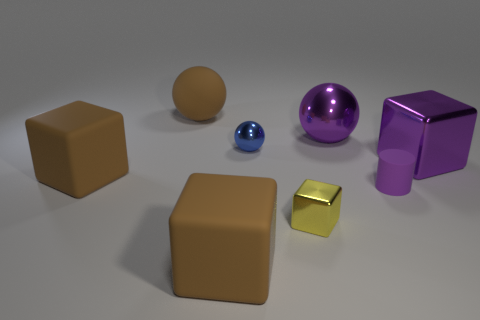What is the color of the big ball in front of the large brown rubber sphere?
Offer a very short reply. Purple. How many big shiny spheres have the same color as the cylinder?
Make the answer very short. 1. Are there fewer small blue balls that are on the left side of the blue shiny sphere than blocks in front of the purple cylinder?
Offer a very short reply. Yes. There is a tiny blue metallic sphere; how many brown things are on the right side of it?
Make the answer very short. 0. Is there a small blue sphere that has the same material as the yellow block?
Your answer should be compact. Yes. Is the number of large metallic balls that are in front of the blue metal thing greater than the number of large purple objects that are behind the large matte sphere?
Provide a short and direct response. No. The purple metallic block is what size?
Offer a very short reply. Large. What is the shape of the small thing right of the tiny yellow block?
Your answer should be compact. Cylinder. Does the tiny yellow metal object have the same shape as the small blue shiny thing?
Provide a succinct answer. No. Are there the same number of brown things in front of the small purple cylinder and big brown rubber spheres?
Your answer should be compact. Yes. 